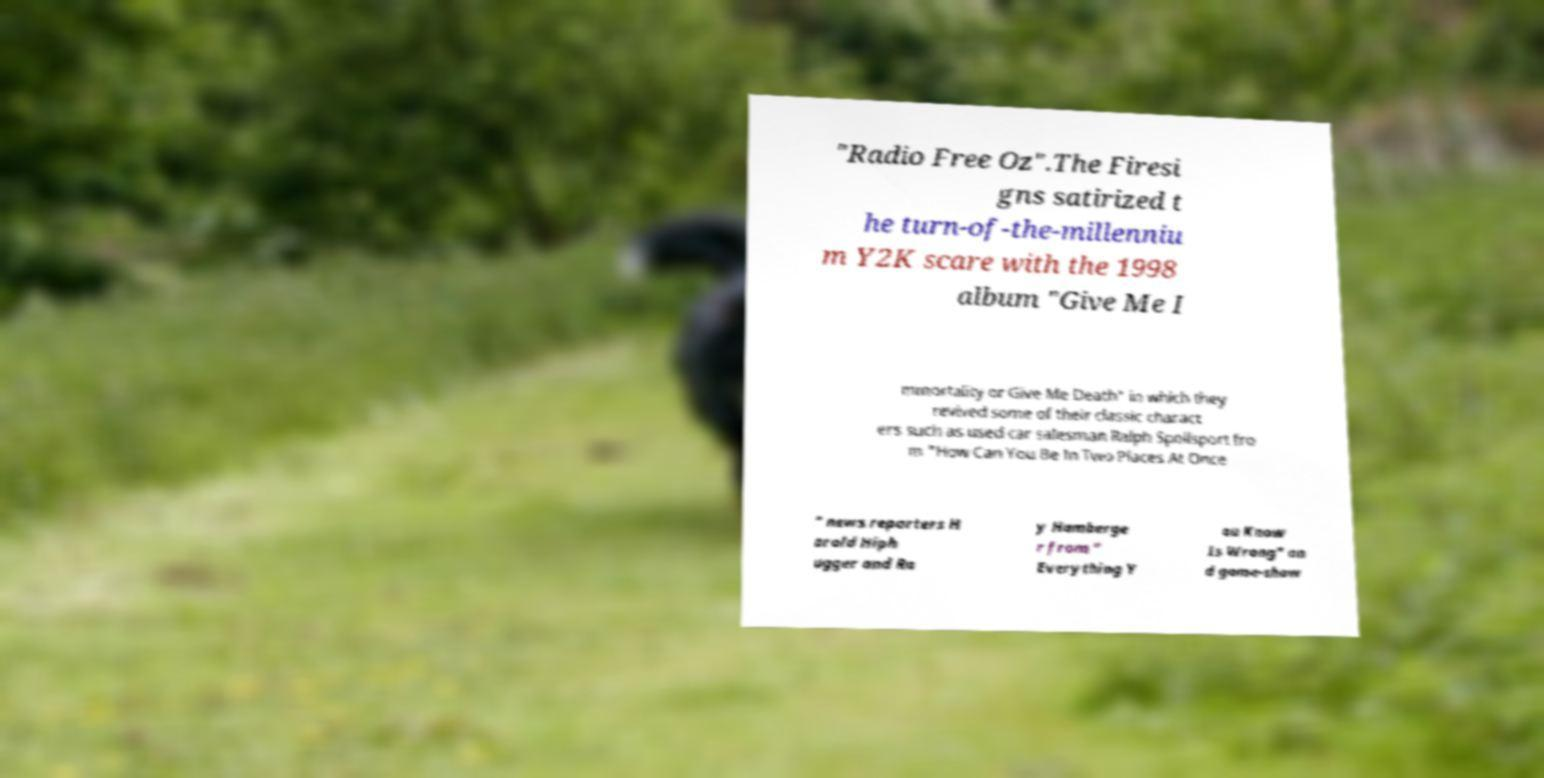Can you read and provide the text displayed in the image?This photo seems to have some interesting text. Can you extract and type it out for me? "Radio Free Oz".The Firesi gns satirized t he turn-of-the-millenniu m Y2K scare with the 1998 album "Give Me I mmortality or Give Me Death" in which they revived some of their classic charact ers such as used car salesman Ralph Spoilsport fro m "How Can You Be In Two Places At Once " news reporters H arold Hiph ugger and Ra y Hamberge r from " Everything Y ou Know Is Wrong" an d game-show 